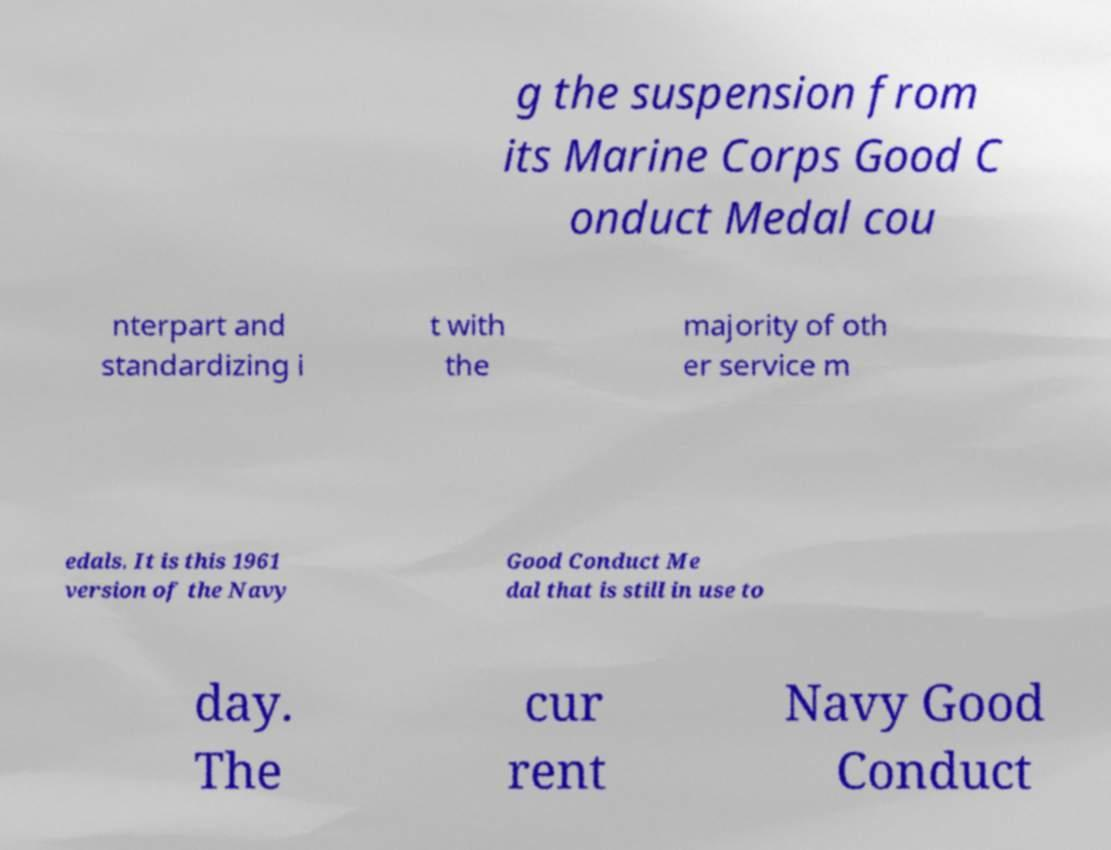Can you accurately transcribe the text from the provided image for me? g the suspension from its Marine Corps Good C onduct Medal cou nterpart and standardizing i t with the majority of oth er service m edals. It is this 1961 version of the Navy Good Conduct Me dal that is still in use to day. The cur rent Navy Good Conduct 